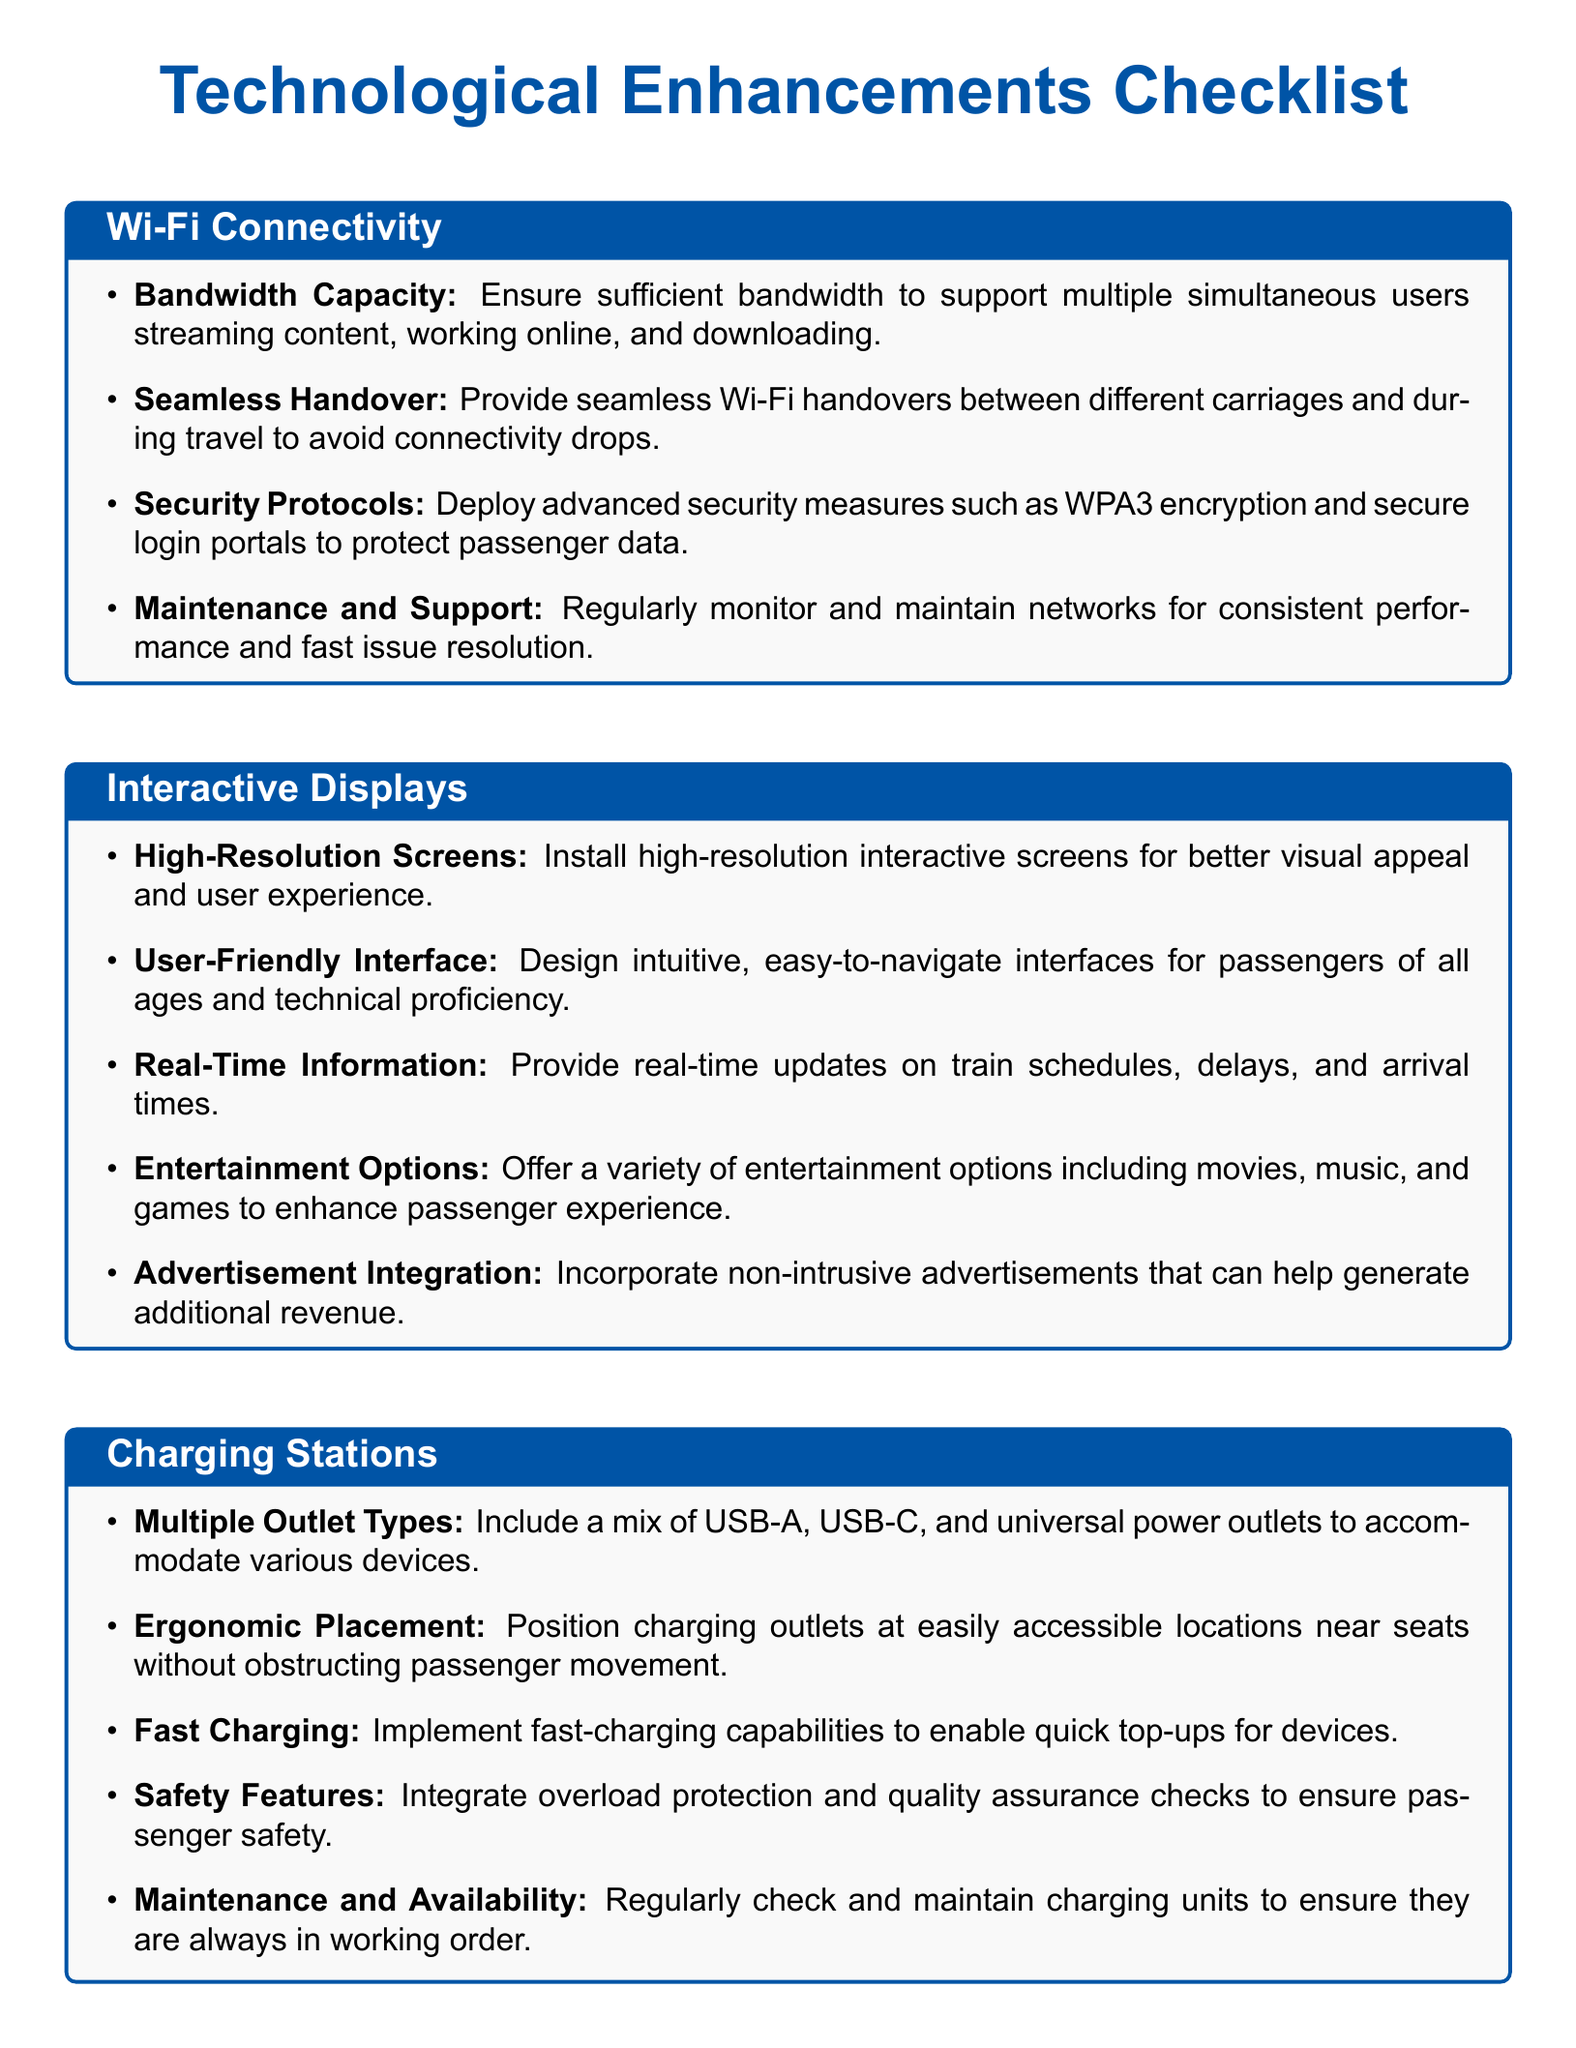What is the bandwidth capacity requirement? The document mentions ensuring sufficient bandwidth to support multiple simultaneous users.
Answer: sufficient bandwidth What kind of interfaces should be designed for interactive displays? An intuitive, easy-to-navigate interface is specified for passengers of all ages and technical proficiency.
Answer: User-Friendly Interface What is one type of security protocol mentioned for Wi-Fi? WPA3 encryption is noted as an advanced security measure to protect passenger data.
Answer: WPA3 encryption What feature is required for charging stations to enable quick top-ups? Fast charging capabilities are mentioned to provide quick device top-ups.
Answer: Fast Charging What kind of screens should be installed for interactive displays? The document states that high-resolution interactive screens should be installed for better visual appeal.
Answer: High-Resolution Screens How should charging outlets be positioned? The document indicates that charging outlets should be positioned at easily accessible locations near seats.
Answer: Ergonomic Placement What type of real-time information is provided on interactive displays? Real-time updates on train schedules, delays, and arrival times are included as information provided.
Answer: train schedules, delays, and arrival times What feature is necessary to ensure passenger safety for charging stations? Overload protection is highlighted as a safety feature that should be integrated into charging stations.
Answer: Overload protection 